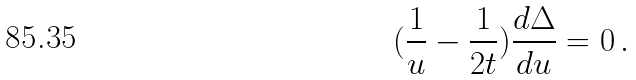<formula> <loc_0><loc_0><loc_500><loc_500>( \frac { 1 } { u } - \frac { 1 } { 2 t } ) \frac { d \Delta } { d u } = 0 \, .</formula> 